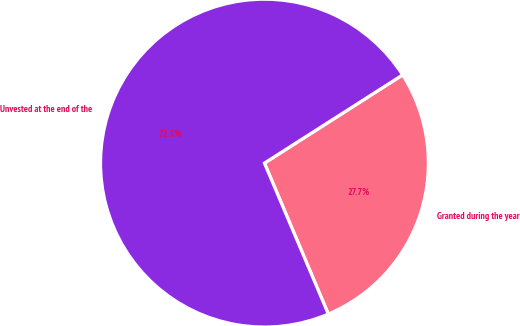<chart> <loc_0><loc_0><loc_500><loc_500><pie_chart><fcel>Granted during the year<fcel>Unvested at the end of the<nl><fcel>27.67%<fcel>72.33%<nl></chart> 